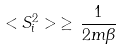Convert formula to latex. <formula><loc_0><loc_0><loc_500><loc_500>< S _ { i } ^ { 2 } > \, \geq \, \frac { 1 } { 2 m \beta }</formula> 